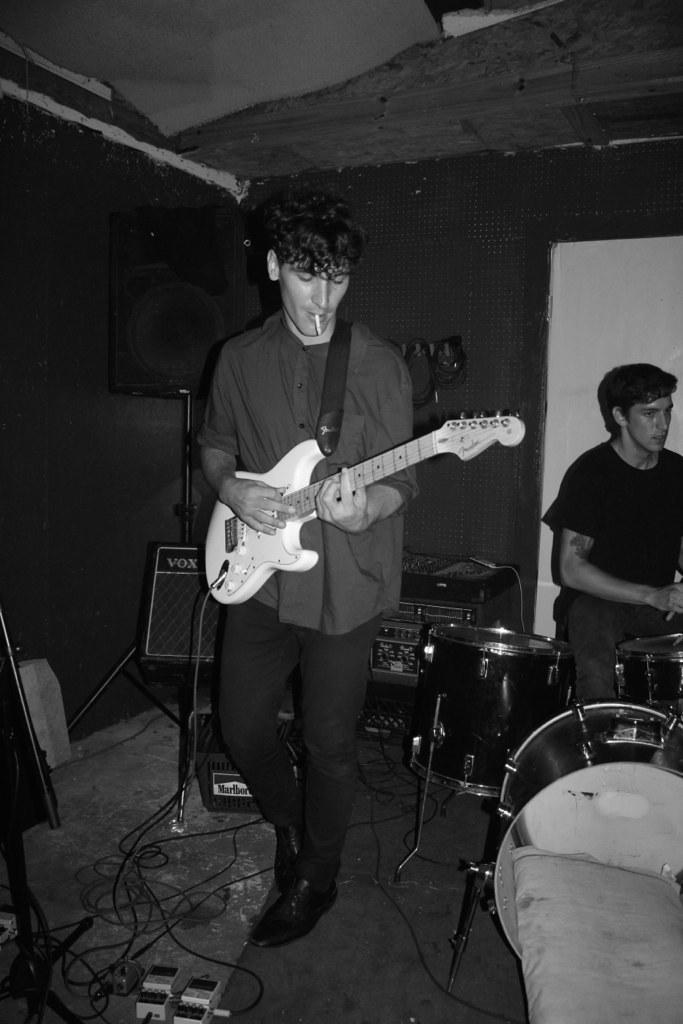Could you give a brief overview of what you see in this image? In this image there are two persons, one is standing and playing guitar and other person sitting and playing drums. At the back there is a speaker, and devices and at the bottom there are wires. 